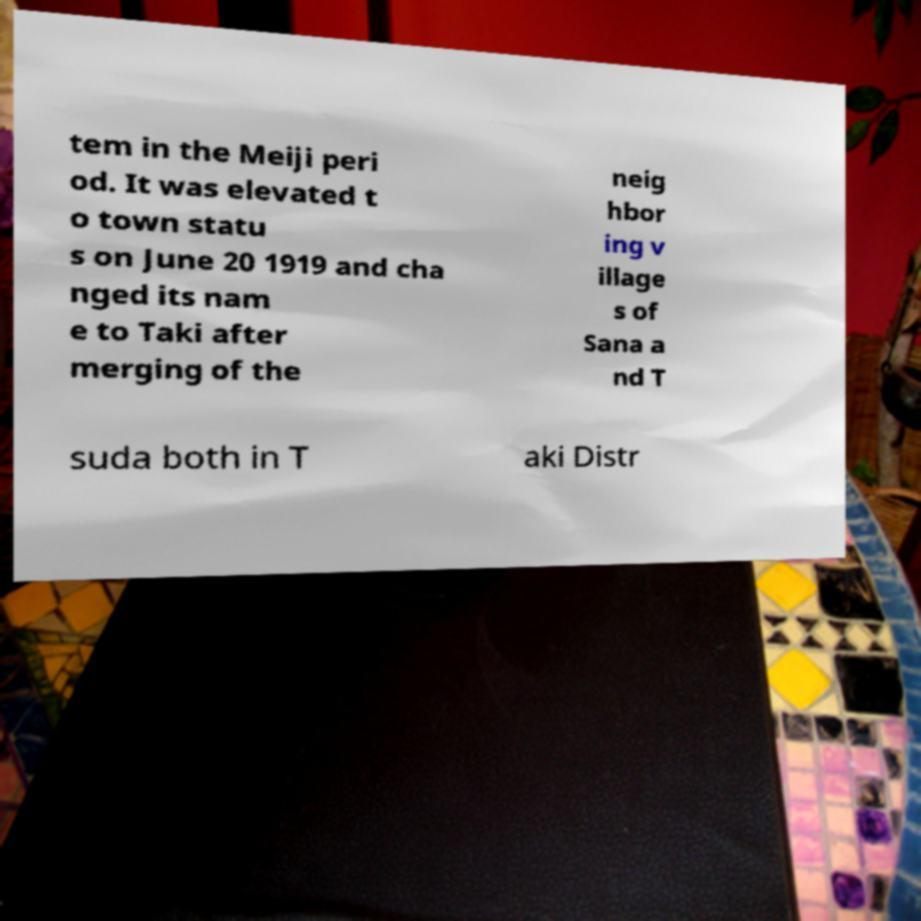Please identify and transcribe the text found in this image. tem in the Meiji peri od. It was elevated t o town statu s on June 20 1919 and cha nged its nam e to Taki after merging of the neig hbor ing v illage s of Sana a nd T suda both in T aki Distr 